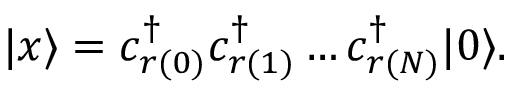<formula> <loc_0><loc_0><loc_500><loc_500>| x \rangle = c _ { r ( 0 ) } ^ { \dagger } c _ { r ( 1 ) } ^ { \dagger } \dots c _ { r ( N ) } ^ { \dagger } | 0 \rangle .</formula> 